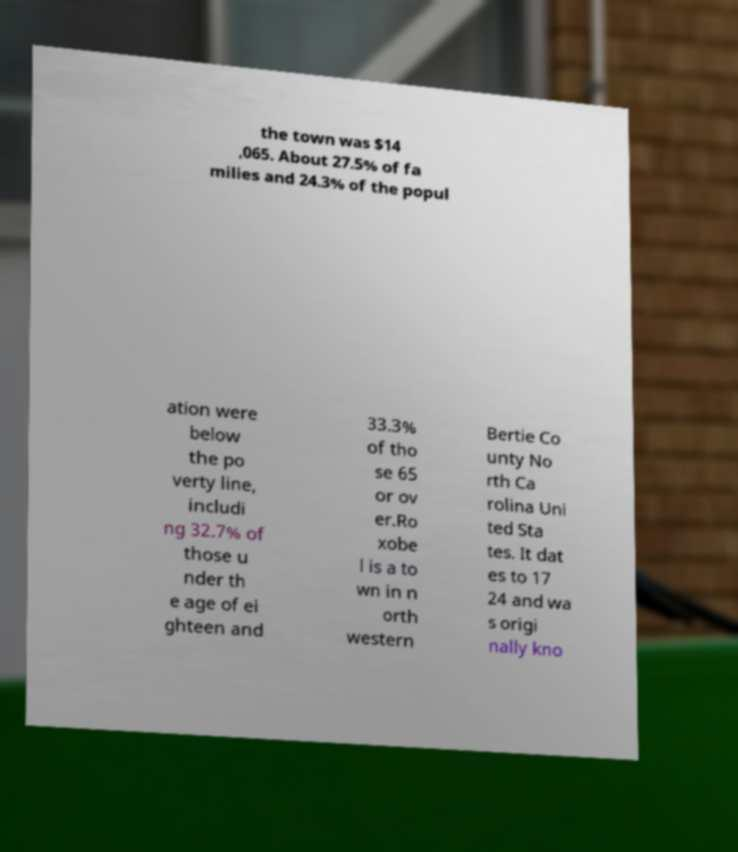For documentation purposes, I need the text within this image transcribed. Could you provide that? the town was $14 ,065. About 27.5% of fa milies and 24.3% of the popul ation were below the po verty line, includi ng 32.7% of those u nder th e age of ei ghteen and 33.3% of tho se 65 or ov er.Ro xobe l is a to wn in n orth western Bertie Co unty No rth Ca rolina Uni ted Sta tes. It dat es to 17 24 and wa s origi nally kno 